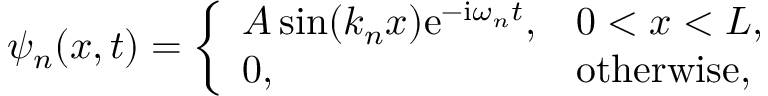Convert formula to latex. <formula><loc_0><loc_0><loc_500><loc_500>\psi _ { n } ( x , t ) = { \left \{ \begin{array} { l l } { A \sin ( k _ { n } x ) e ^ { - i \omega _ { n } t } , } & { 0 < x < L , } \\ { 0 , } & { o t h e r w i s e , } \end{array} }</formula> 